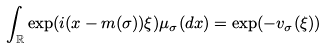<formula> <loc_0><loc_0><loc_500><loc_500>\int _ { \mathbb { R } } { \exp ( i ( x - m ( \sigma ) ) \xi ) \mu _ { \sigma } ( d x ) } = \exp ( - v _ { \sigma } ( \xi ) )</formula> 